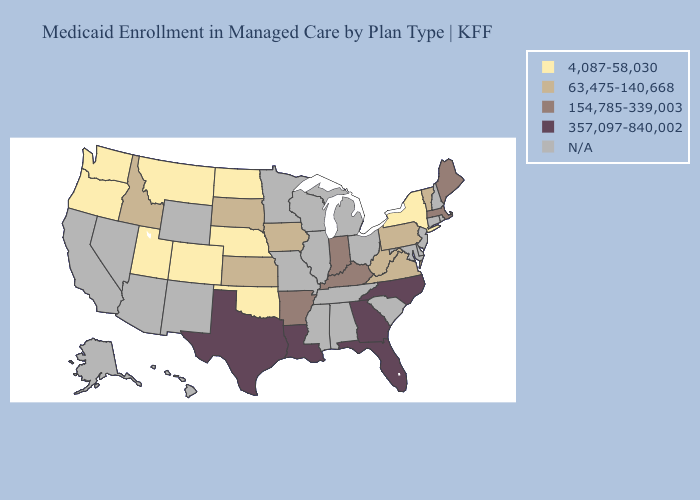Does Oklahoma have the lowest value in the South?
Write a very short answer. Yes. Name the states that have a value in the range 357,097-840,002?
Keep it brief. Florida, Georgia, Louisiana, North Carolina, Texas. What is the value of South Dakota?
Concise answer only. 63,475-140,668. Name the states that have a value in the range 4,087-58,030?
Write a very short answer. Colorado, Montana, Nebraska, New York, North Dakota, Oklahoma, Oregon, Utah, Washington. What is the value of Mississippi?
Concise answer only. N/A. Name the states that have a value in the range 63,475-140,668?
Short answer required. Idaho, Iowa, Kansas, Pennsylvania, South Dakota, Vermont, Virginia, West Virginia. Does the first symbol in the legend represent the smallest category?
Give a very brief answer. Yes. Does the map have missing data?
Give a very brief answer. Yes. What is the lowest value in states that border California?
Keep it brief. 4,087-58,030. Name the states that have a value in the range 63,475-140,668?
Write a very short answer. Idaho, Iowa, Kansas, Pennsylvania, South Dakota, Vermont, Virginia, West Virginia. Among the states that border South Carolina , which have the lowest value?
Be succinct. Georgia, North Carolina. Name the states that have a value in the range 63,475-140,668?
Concise answer only. Idaho, Iowa, Kansas, Pennsylvania, South Dakota, Vermont, Virginia, West Virginia. Name the states that have a value in the range N/A?
Give a very brief answer. Alabama, Alaska, Arizona, California, Connecticut, Delaware, Hawaii, Illinois, Maryland, Michigan, Minnesota, Mississippi, Missouri, Nevada, New Hampshire, New Jersey, New Mexico, Ohio, Rhode Island, South Carolina, Tennessee, Wisconsin, Wyoming. What is the lowest value in the Northeast?
Short answer required. 4,087-58,030. What is the value of Maryland?
Keep it brief. N/A. 